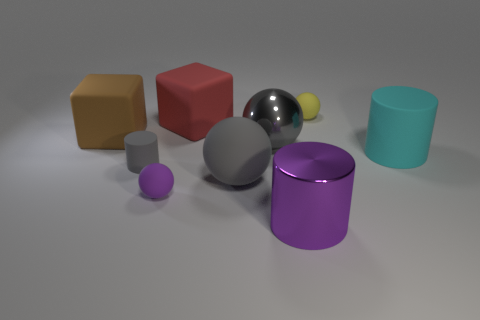Add 1 small red metal spheres. How many objects exist? 10 Subtract all spheres. How many objects are left? 5 Subtract 1 cyan cylinders. How many objects are left? 8 Subtract all gray matte things. Subtract all big red rubber things. How many objects are left? 6 Add 5 large rubber things. How many large rubber things are left? 9 Add 1 tiny cyan metallic objects. How many tiny cyan metallic objects exist? 1 